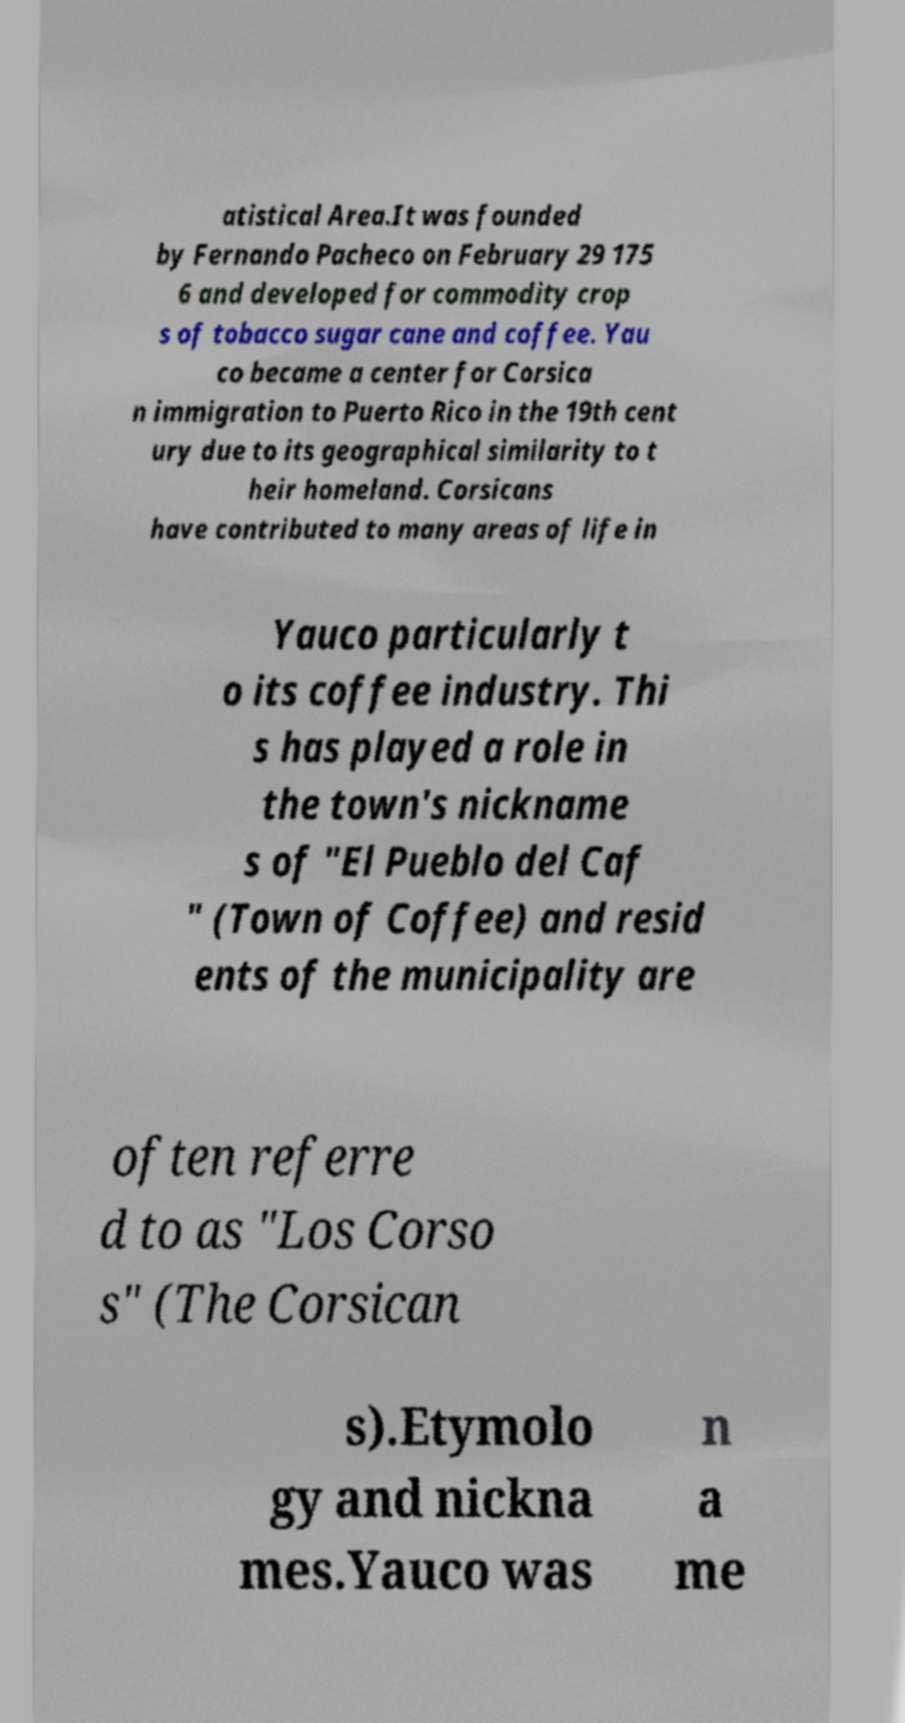Please identify and transcribe the text found in this image. atistical Area.It was founded by Fernando Pacheco on February 29 175 6 and developed for commodity crop s of tobacco sugar cane and coffee. Yau co became a center for Corsica n immigration to Puerto Rico in the 19th cent ury due to its geographical similarity to t heir homeland. Corsicans have contributed to many areas of life in Yauco particularly t o its coffee industry. Thi s has played a role in the town's nickname s of "El Pueblo del Caf " (Town of Coffee) and resid ents of the municipality are often referre d to as "Los Corso s" (The Corsican s).Etymolo gy and nickna mes.Yauco was n a me 